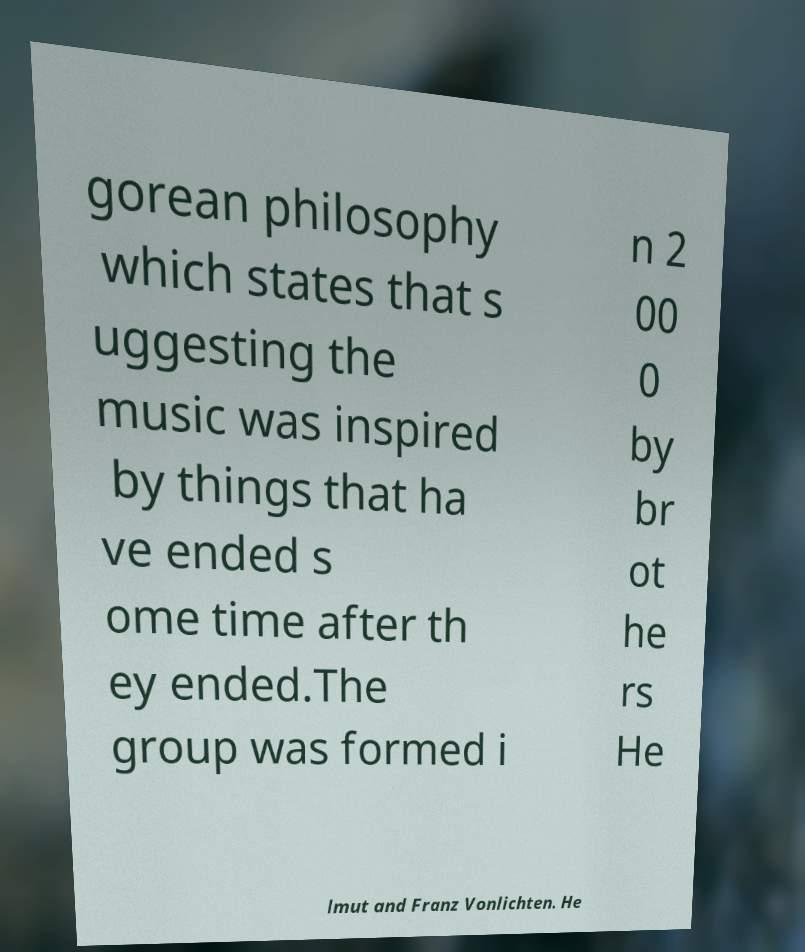Can you accurately transcribe the text from the provided image for me? gorean philosophy which states that s uggesting the music was inspired by things that ha ve ended s ome time after th ey ended.The group was formed i n 2 00 0 by br ot he rs He lmut and Franz Vonlichten. He 